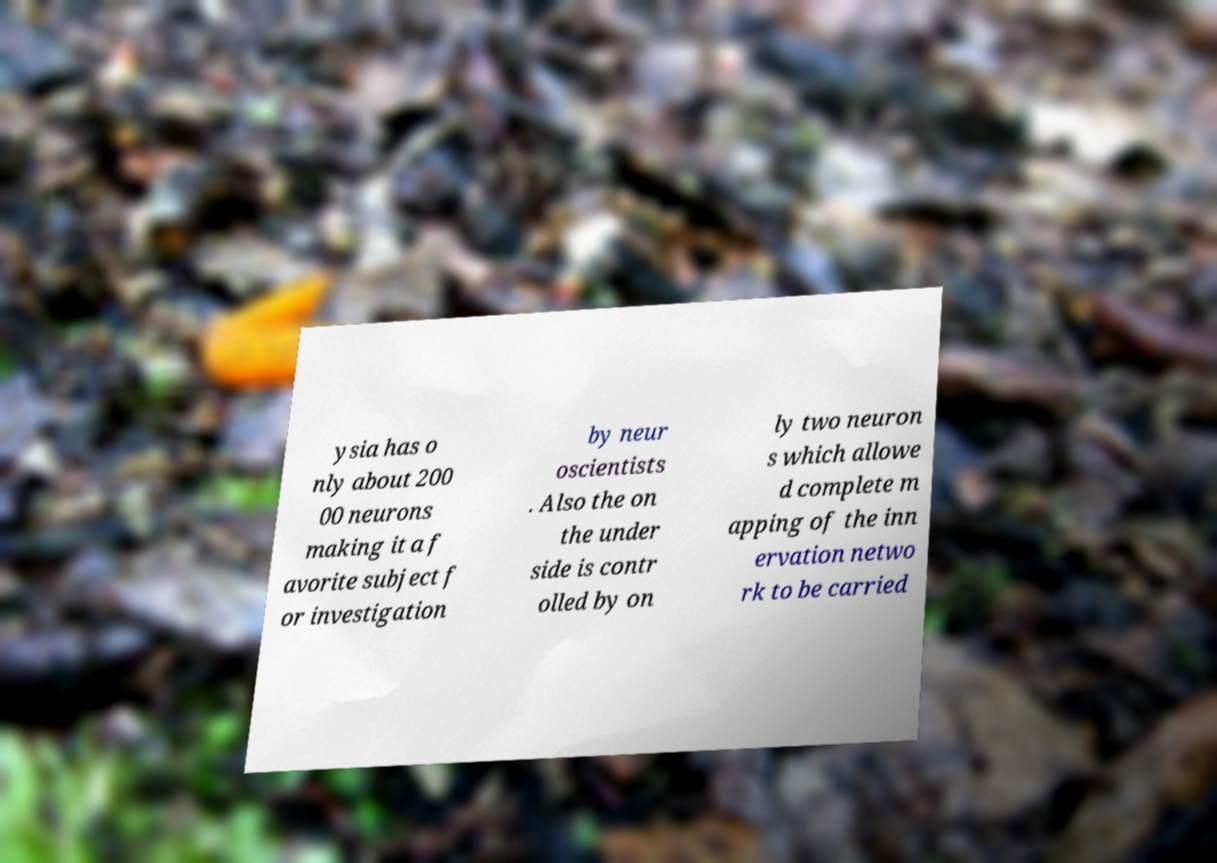There's text embedded in this image that I need extracted. Can you transcribe it verbatim? ysia has o nly about 200 00 neurons making it a f avorite subject f or investigation by neur oscientists . Also the on the under side is contr olled by on ly two neuron s which allowe d complete m apping of the inn ervation netwo rk to be carried 